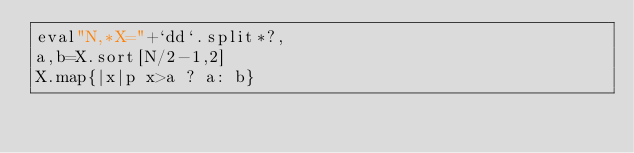<code> <loc_0><loc_0><loc_500><loc_500><_Ruby_>eval"N,*X="+`dd`.split*?,
a,b=X.sort[N/2-1,2]
X.map{|x|p x>a ? a: b}</code> 